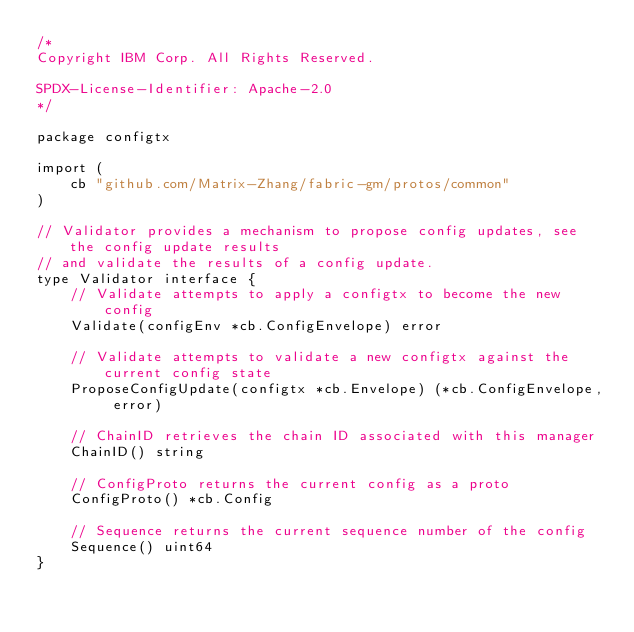<code> <loc_0><loc_0><loc_500><loc_500><_Go_>/*
Copyright IBM Corp. All Rights Reserved.

SPDX-License-Identifier: Apache-2.0
*/

package configtx

import (
	cb "github.com/Matrix-Zhang/fabric-gm/protos/common"
)

// Validator provides a mechanism to propose config updates, see the config update results
// and validate the results of a config update.
type Validator interface {
	// Validate attempts to apply a configtx to become the new config
	Validate(configEnv *cb.ConfigEnvelope) error

	// Validate attempts to validate a new configtx against the current config state
	ProposeConfigUpdate(configtx *cb.Envelope) (*cb.ConfigEnvelope, error)

	// ChainID retrieves the chain ID associated with this manager
	ChainID() string

	// ConfigProto returns the current config as a proto
	ConfigProto() *cb.Config

	// Sequence returns the current sequence number of the config
	Sequence() uint64
}
</code> 